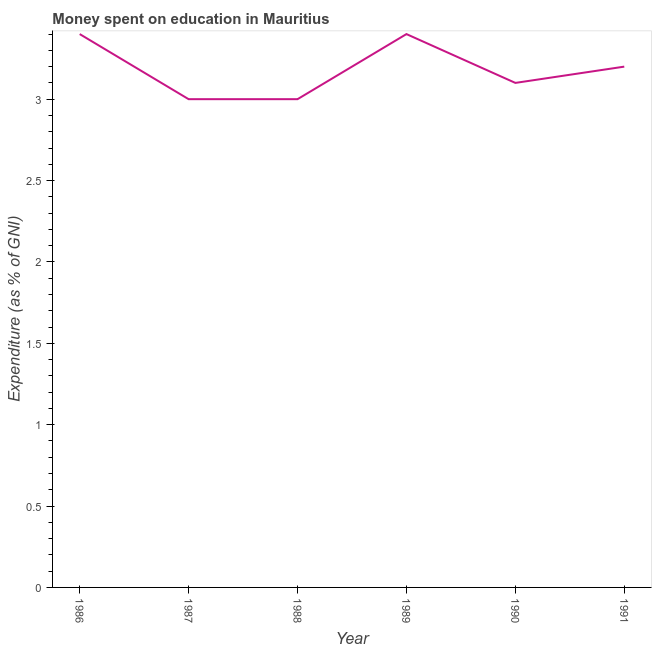Across all years, what is the minimum expenditure on education?
Keep it short and to the point. 3. What is the difference between the expenditure on education in 1986 and 1990?
Offer a very short reply. 0.3. What is the average expenditure on education per year?
Provide a succinct answer. 3.18. What is the median expenditure on education?
Offer a very short reply. 3.15. What is the ratio of the expenditure on education in 1986 to that in 1987?
Offer a very short reply. 1.13. Is the difference between the expenditure on education in 1987 and 1991 greater than the difference between any two years?
Keep it short and to the point. No. Is the sum of the expenditure on education in 1987 and 1990 greater than the maximum expenditure on education across all years?
Offer a terse response. Yes. What is the difference between the highest and the lowest expenditure on education?
Provide a succinct answer. 0.4. In how many years, is the expenditure on education greater than the average expenditure on education taken over all years?
Provide a succinct answer. 3. How many lines are there?
Give a very brief answer. 1. How many years are there in the graph?
Your response must be concise. 6. What is the difference between two consecutive major ticks on the Y-axis?
Your answer should be compact. 0.5. Are the values on the major ticks of Y-axis written in scientific E-notation?
Keep it short and to the point. No. Does the graph contain grids?
Your response must be concise. No. What is the title of the graph?
Provide a succinct answer. Money spent on education in Mauritius. What is the label or title of the Y-axis?
Give a very brief answer. Expenditure (as % of GNI). What is the Expenditure (as % of GNI) of 1987?
Give a very brief answer. 3. What is the difference between the Expenditure (as % of GNI) in 1986 and 1987?
Your answer should be very brief. 0.4. What is the difference between the Expenditure (as % of GNI) in 1987 and 1990?
Keep it short and to the point. -0.1. What is the difference between the Expenditure (as % of GNI) in 1988 and 1991?
Your answer should be very brief. -0.2. What is the difference between the Expenditure (as % of GNI) in 1990 and 1991?
Your answer should be compact. -0.1. What is the ratio of the Expenditure (as % of GNI) in 1986 to that in 1987?
Your answer should be very brief. 1.13. What is the ratio of the Expenditure (as % of GNI) in 1986 to that in 1988?
Your answer should be compact. 1.13. What is the ratio of the Expenditure (as % of GNI) in 1986 to that in 1990?
Your response must be concise. 1.1. What is the ratio of the Expenditure (as % of GNI) in 1986 to that in 1991?
Make the answer very short. 1.06. What is the ratio of the Expenditure (as % of GNI) in 1987 to that in 1988?
Offer a very short reply. 1. What is the ratio of the Expenditure (as % of GNI) in 1987 to that in 1989?
Ensure brevity in your answer.  0.88. What is the ratio of the Expenditure (as % of GNI) in 1987 to that in 1990?
Your response must be concise. 0.97. What is the ratio of the Expenditure (as % of GNI) in 1987 to that in 1991?
Provide a short and direct response. 0.94. What is the ratio of the Expenditure (as % of GNI) in 1988 to that in 1989?
Make the answer very short. 0.88. What is the ratio of the Expenditure (as % of GNI) in 1988 to that in 1991?
Your answer should be compact. 0.94. What is the ratio of the Expenditure (as % of GNI) in 1989 to that in 1990?
Give a very brief answer. 1.1. What is the ratio of the Expenditure (as % of GNI) in 1989 to that in 1991?
Your answer should be very brief. 1.06. 